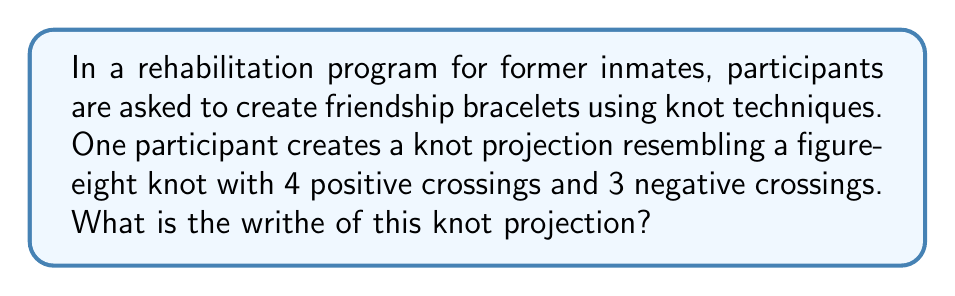Help me with this question. To determine the writhe of a knot projection, we follow these steps:

1. Understand the concept of writhe:
   The writhe of a knot projection is the sum of the signs of all crossings in the projection.

2. Identify the crossings:
   In this case, we have:
   - 4 positive crossings
   - 3 negative crossings

3. Assign values to the crossings:
   - Positive crossings: +1
   - Negative crossings: -1

4. Calculate the sum:
   $$\text{Writhe} = (\text{Number of positive crossings} \times (+1)) + (\text{Number of negative crossings} \times (-1))$$
   $$\text{Writhe} = (4 \times (+1)) + (3 \times (-1))$$
   $$\text{Writhe} = 4 - 3$$
   $$\text{Writhe} = 1$$

Therefore, the writhe of the knot projection created by the participant is 1.
Answer: 1 